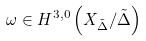<formula> <loc_0><loc_0><loc_500><loc_500>\omega \in H ^ { 3 , 0 } \left ( X _ { \tilde { \Delta } } / \tilde { \Delta } \right )</formula> 